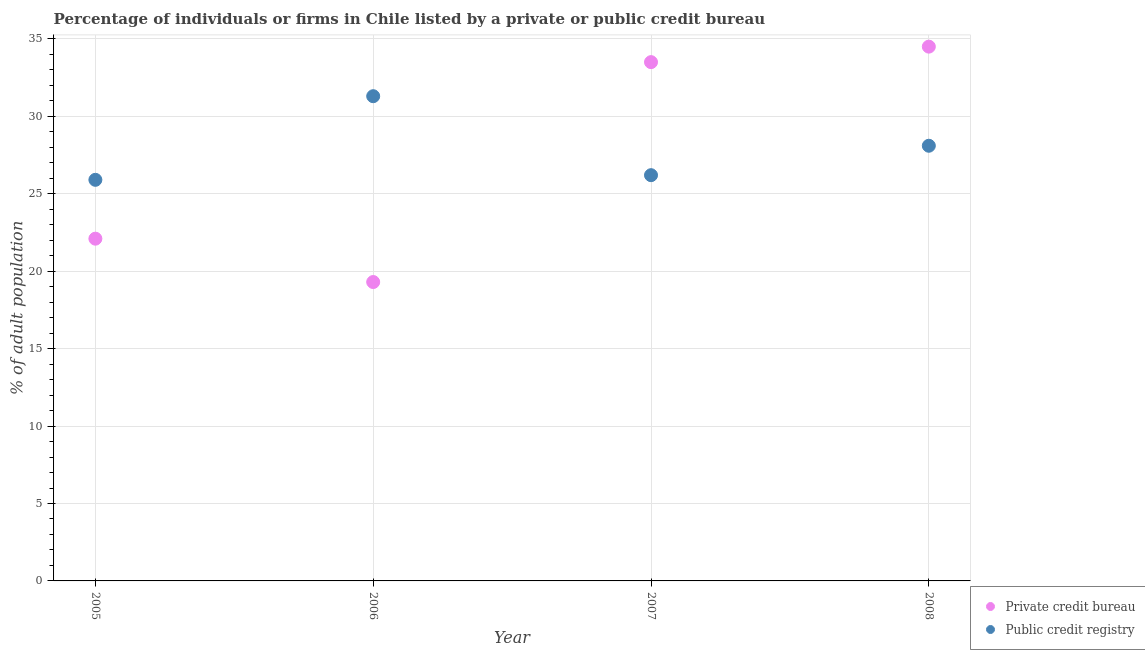How many different coloured dotlines are there?
Offer a very short reply. 2. What is the percentage of firms listed by public credit bureau in 2007?
Your answer should be compact. 26.2. Across all years, what is the maximum percentage of firms listed by private credit bureau?
Provide a short and direct response. 34.5. Across all years, what is the minimum percentage of firms listed by public credit bureau?
Provide a succinct answer. 25.9. In which year was the percentage of firms listed by public credit bureau maximum?
Make the answer very short. 2006. What is the total percentage of firms listed by public credit bureau in the graph?
Offer a very short reply. 111.5. What is the difference between the percentage of firms listed by public credit bureau in 2005 and that in 2007?
Provide a succinct answer. -0.3. What is the average percentage of firms listed by private credit bureau per year?
Give a very brief answer. 27.35. In the year 2007, what is the difference between the percentage of firms listed by public credit bureau and percentage of firms listed by private credit bureau?
Make the answer very short. -7.3. In how many years, is the percentage of firms listed by public credit bureau greater than 5 %?
Make the answer very short. 4. What is the ratio of the percentage of firms listed by public credit bureau in 2007 to that in 2008?
Provide a short and direct response. 0.93. Is the percentage of firms listed by public credit bureau in 2006 less than that in 2007?
Offer a very short reply. No. Is the difference between the percentage of firms listed by private credit bureau in 2006 and 2007 greater than the difference between the percentage of firms listed by public credit bureau in 2006 and 2007?
Your response must be concise. No. What is the difference between the highest and the second highest percentage of firms listed by public credit bureau?
Your answer should be compact. 3.2. What is the difference between the highest and the lowest percentage of firms listed by private credit bureau?
Ensure brevity in your answer.  15.2. Does the percentage of firms listed by private credit bureau monotonically increase over the years?
Make the answer very short. No. Is the percentage of firms listed by private credit bureau strictly greater than the percentage of firms listed by public credit bureau over the years?
Provide a succinct answer. No. How many dotlines are there?
Your answer should be compact. 2. What is the difference between two consecutive major ticks on the Y-axis?
Give a very brief answer. 5. Does the graph contain grids?
Offer a very short reply. Yes. Where does the legend appear in the graph?
Make the answer very short. Bottom right. How many legend labels are there?
Offer a very short reply. 2. How are the legend labels stacked?
Offer a terse response. Vertical. What is the title of the graph?
Provide a succinct answer. Percentage of individuals or firms in Chile listed by a private or public credit bureau. What is the label or title of the X-axis?
Offer a terse response. Year. What is the label or title of the Y-axis?
Your response must be concise. % of adult population. What is the % of adult population of Private credit bureau in 2005?
Make the answer very short. 22.1. What is the % of adult population of Public credit registry in 2005?
Your answer should be very brief. 25.9. What is the % of adult population in Private credit bureau in 2006?
Your answer should be very brief. 19.3. What is the % of adult population of Public credit registry in 2006?
Keep it short and to the point. 31.3. What is the % of adult population in Private credit bureau in 2007?
Your answer should be compact. 33.5. What is the % of adult population of Public credit registry in 2007?
Provide a succinct answer. 26.2. What is the % of adult population in Private credit bureau in 2008?
Provide a short and direct response. 34.5. What is the % of adult population in Public credit registry in 2008?
Make the answer very short. 28.1. Across all years, what is the maximum % of adult population in Private credit bureau?
Provide a succinct answer. 34.5. Across all years, what is the maximum % of adult population of Public credit registry?
Keep it short and to the point. 31.3. Across all years, what is the minimum % of adult population of Private credit bureau?
Ensure brevity in your answer.  19.3. Across all years, what is the minimum % of adult population of Public credit registry?
Give a very brief answer. 25.9. What is the total % of adult population in Private credit bureau in the graph?
Ensure brevity in your answer.  109.4. What is the total % of adult population in Public credit registry in the graph?
Give a very brief answer. 111.5. What is the difference between the % of adult population of Public credit registry in 2005 and that in 2007?
Provide a short and direct response. -0.3. What is the difference between the % of adult population in Public credit registry in 2006 and that in 2007?
Your answer should be compact. 5.1. What is the difference between the % of adult population in Private credit bureau in 2006 and that in 2008?
Offer a very short reply. -15.2. What is the difference between the % of adult population of Private credit bureau in 2007 and that in 2008?
Offer a very short reply. -1. What is the difference between the % of adult population in Public credit registry in 2007 and that in 2008?
Your answer should be very brief. -1.9. What is the difference between the % of adult population of Private credit bureau in 2005 and the % of adult population of Public credit registry in 2006?
Your response must be concise. -9.2. What is the difference between the % of adult population of Private credit bureau in 2005 and the % of adult population of Public credit registry in 2007?
Offer a very short reply. -4.1. What is the difference between the % of adult population in Private credit bureau in 2005 and the % of adult population in Public credit registry in 2008?
Offer a very short reply. -6. What is the difference between the % of adult population of Private credit bureau in 2007 and the % of adult population of Public credit registry in 2008?
Ensure brevity in your answer.  5.4. What is the average % of adult population in Private credit bureau per year?
Provide a succinct answer. 27.35. What is the average % of adult population in Public credit registry per year?
Ensure brevity in your answer.  27.88. In the year 2005, what is the difference between the % of adult population in Private credit bureau and % of adult population in Public credit registry?
Give a very brief answer. -3.8. In the year 2006, what is the difference between the % of adult population of Private credit bureau and % of adult population of Public credit registry?
Offer a very short reply. -12. In the year 2008, what is the difference between the % of adult population of Private credit bureau and % of adult population of Public credit registry?
Your answer should be compact. 6.4. What is the ratio of the % of adult population in Private credit bureau in 2005 to that in 2006?
Offer a very short reply. 1.15. What is the ratio of the % of adult population of Public credit registry in 2005 to that in 2006?
Ensure brevity in your answer.  0.83. What is the ratio of the % of adult population of Private credit bureau in 2005 to that in 2007?
Your response must be concise. 0.66. What is the ratio of the % of adult population of Private credit bureau in 2005 to that in 2008?
Provide a succinct answer. 0.64. What is the ratio of the % of adult population in Public credit registry in 2005 to that in 2008?
Keep it short and to the point. 0.92. What is the ratio of the % of adult population of Private credit bureau in 2006 to that in 2007?
Provide a short and direct response. 0.58. What is the ratio of the % of adult population of Public credit registry in 2006 to that in 2007?
Your response must be concise. 1.19. What is the ratio of the % of adult population in Private credit bureau in 2006 to that in 2008?
Give a very brief answer. 0.56. What is the ratio of the % of adult population of Public credit registry in 2006 to that in 2008?
Keep it short and to the point. 1.11. What is the ratio of the % of adult population of Private credit bureau in 2007 to that in 2008?
Provide a short and direct response. 0.97. What is the ratio of the % of adult population of Public credit registry in 2007 to that in 2008?
Provide a succinct answer. 0.93. What is the difference between the highest and the second highest % of adult population of Private credit bureau?
Keep it short and to the point. 1. What is the difference between the highest and the lowest % of adult population of Public credit registry?
Your answer should be very brief. 5.4. 